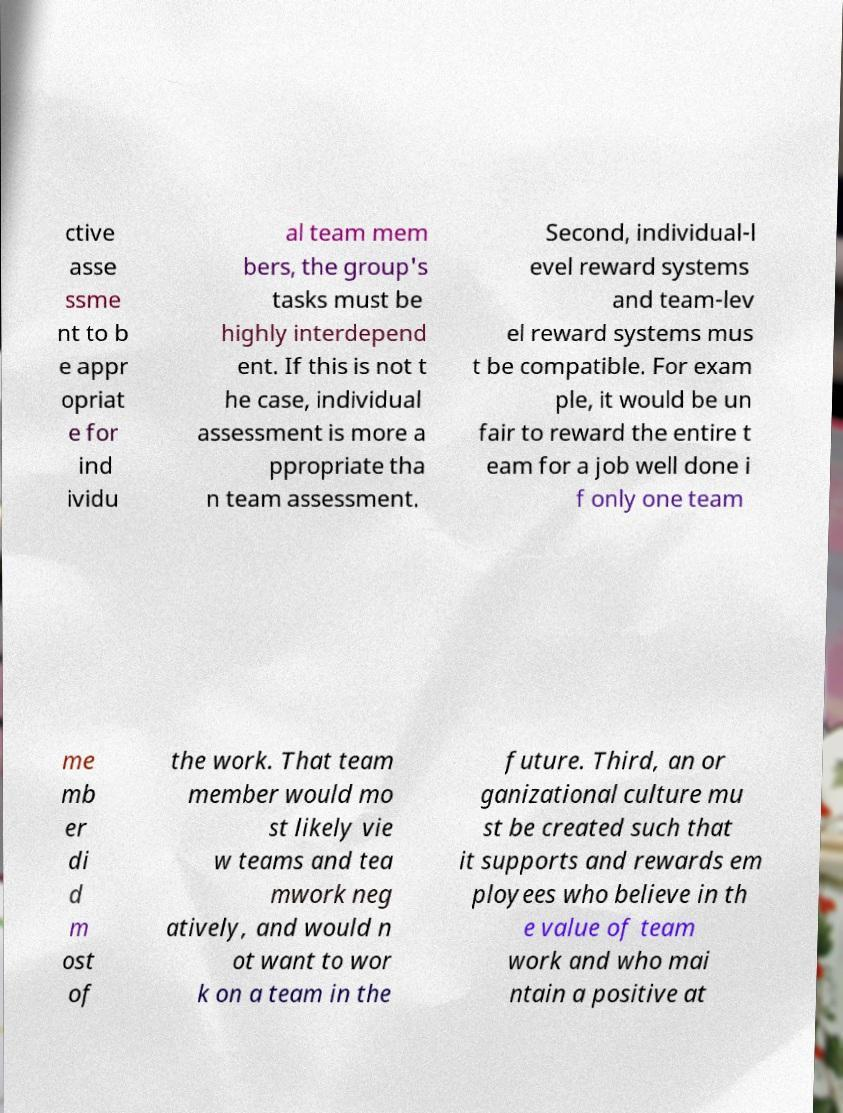Please read and relay the text visible in this image. What does it say? ctive asse ssme nt to b e appr opriat e for ind ividu al team mem bers, the group's tasks must be highly interdepend ent. If this is not t he case, individual assessment is more a ppropriate tha n team assessment. Second, individual-l evel reward systems and team-lev el reward systems mus t be compatible. For exam ple, it would be un fair to reward the entire t eam for a job well done i f only one team me mb er di d m ost of the work. That team member would mo st likely vie w teams and tea mwork neg atively, and would n ot want to wor k on a team in the future. Third, an or ganizational culture mu st be created such that it supports and rewards em ployees who believe in th e value of team work and who mai ntain a positive at 